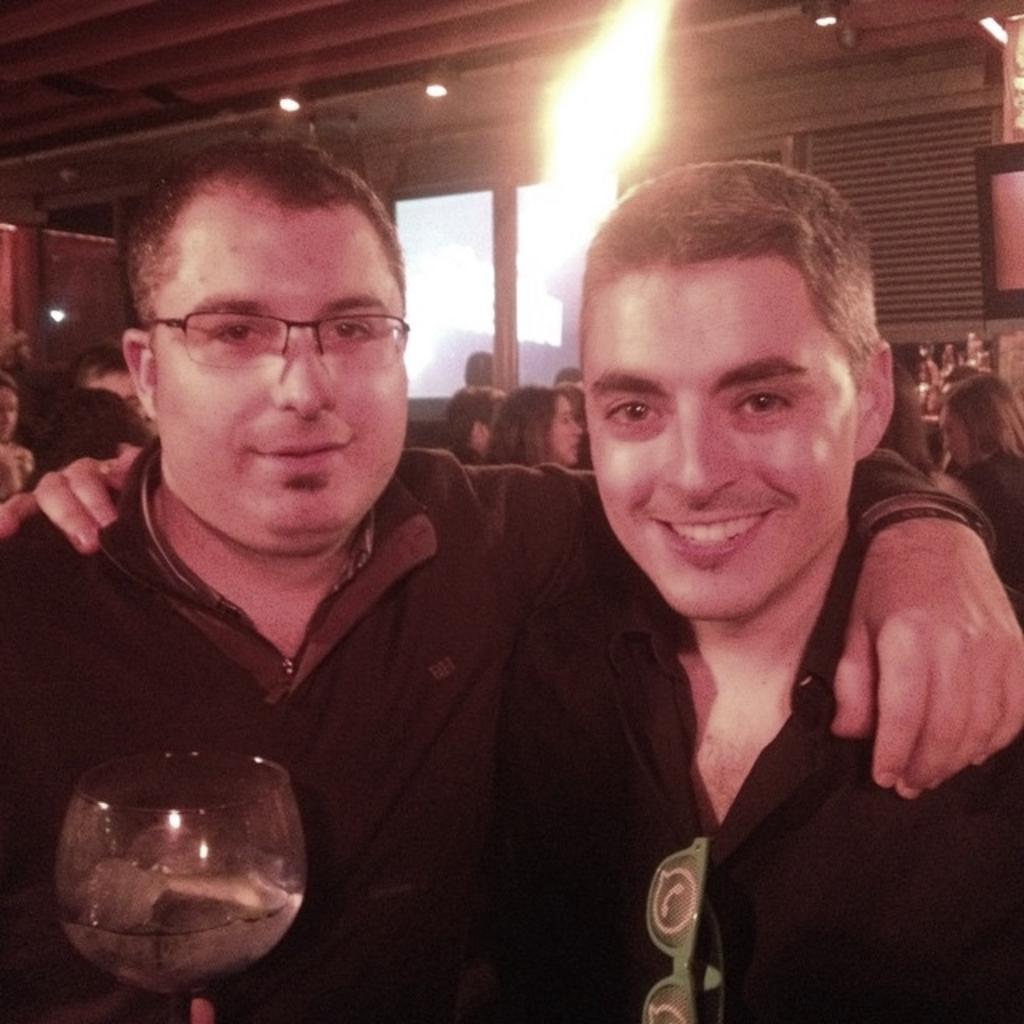Could you give a brief overview of what you see in this image? There is a group of people. in the center both persons are smiling. On the right side of the person is wearing a spectacle. On the left side of the person is wearing a spectacle and holding a glass. We can see in the background wall,sky,roof ,pillar. 